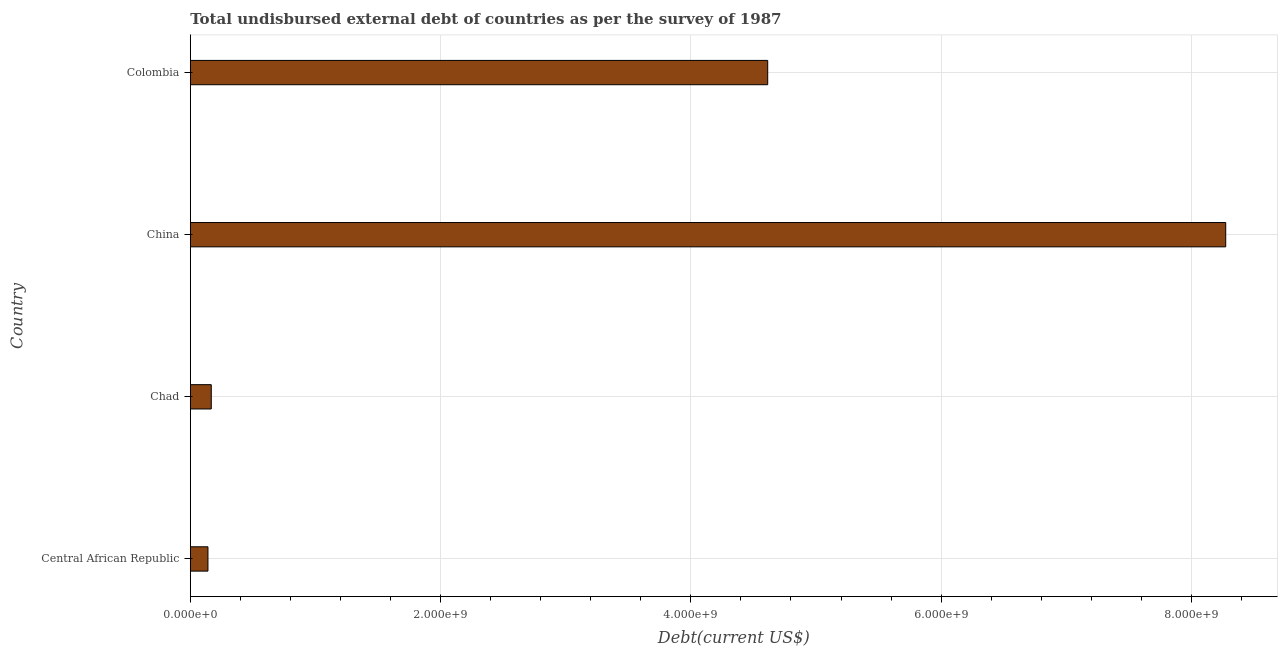What is the title of the graph?
Your answer should be compact. Total undisbursed external debt of countries as per the survey of 1987. What is the label or title of the X-axis?
Your answer should be very brief. Debt(current US$). What is the total debt in Central African Republic?
Give a very brief answer. 1.41e+08. Across all countries, what is the maximum total debt?
Your answer should be very brief. 8.27e+09. Across all countries, what is the minimum total debt?
Keep it short and to the point. 1.41e+08. In which country was the total debt maximum?
Give a very brief answer. China. In which country was the total debt minimum?
Provide a short and direct response. Central African Republic. What is the sum of the total debt?
Your answer should be compact. 1.32e+1. What is the difference between the total debt in Chad and China?
Your answer should be very brief. -8.11e+09. What is the average total debt per country?
Provide a short and direct response. 3.30e+09. What is the median total debt?
Your answer should be compact. 2.39e+09. What is the ratio of the total debt in Chad to that in Colombia?
Your answer should be very brief. 0.04. What is the difference between the highest and the second highest total debt?
Give a very brief answer. 3.66e+09. What is the difference between the highest and the lowest total debt?
Offer a very short reply. 8.13e+09. Are all the bars in the graph horizontal?
Make the answer very short. Yes. How many countries are there in the graph?
Provide a short and direct response. 4. What is the Debt(current US$) in Central African Republic?
Make the answer very short. 1.41e+08. What is the Debt(current US$) in Chad?
Provide a short and direct response. 1.68e+08. What is the Debt(current US$) in China?
Your answer should be very brief. 8.27e+09. What is the Debt(current US$) in Colombia?
Ensure brevity in your answer.  4.61e+09. What is the difference between the Debt(current US$) in Central African Republic and Chad?
Ensure brevity in your answer.  -2.65e+07. What is the difference between the Debt(current US$) in Central African Republic and China?
Provide a short and direct response. -8.13e+09. What is the difference between the Debt(current US$) in Central African Republic and Colombia?
Make the answer very short. -4.47e+09. What is the difference between the Debt(current US$) in Chad and China?
Offer a terse response. -8.11e+09. What is the difference between the Debt(current US$) in Chad and Colombia?
Your answer should be compact. -4.45e+09. What is the difference between the Debt(current US$) in China and Colombia?
Keep it short and to the point. 3.66e+09. What is the ratio of the Debt(current US$) in Central African Republic to that in Chad?
Provide a short and direct response. 0.84. What is the ratio of the Debt(current US$) in Central African Republic to that in China?
Your answer should be compact. 0.02. What is the ratio of the Debt(current US$) in Central African Republic to that in Colombia?
Provide a short and direct response. 0.03. What is the ratio of the Debt(current US$) in Chad to that in China?
Make the answer very short. 0.02. What is the ratio of the Debt(current US$) in Chad to that in Colombia?
Give a very brief answer. 0.04. What is the ratio of the Debt(current US$) in China to that in Colombia?
Your answer should be compact. 1.79. 